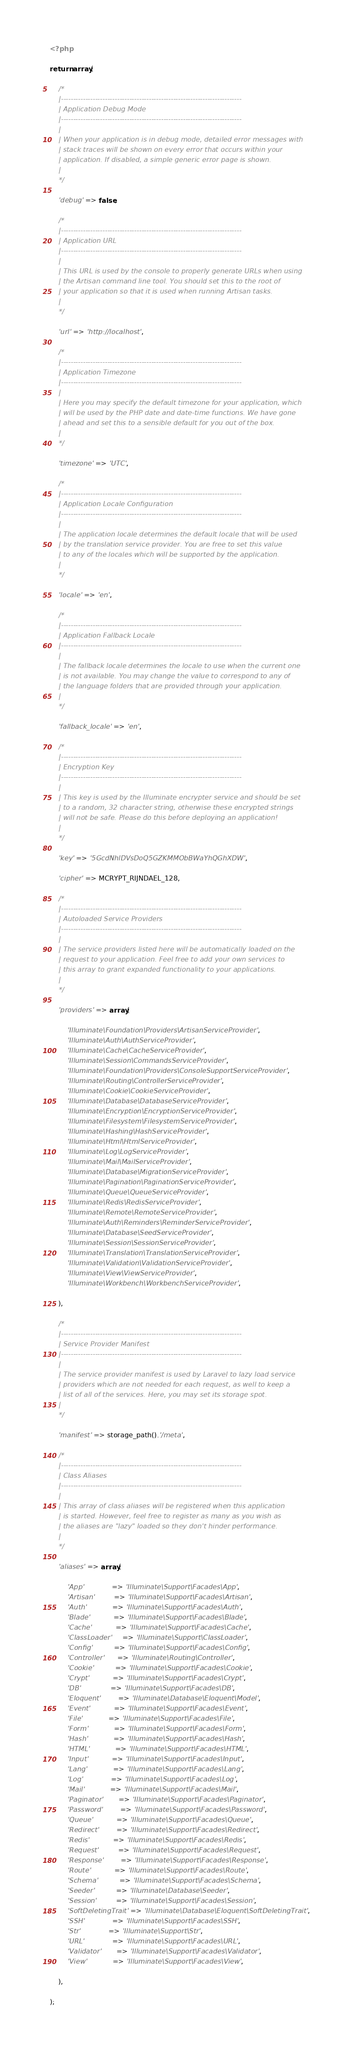Convert code to text. <code><loc_0><loc_0><loc_500><loc_500><_PHP_><?php

return array(

	/*
	|--------------------------------------------------------------------------
	| Application Debug Mode
	|--------------------------------------------------------------------------
	|
	| When your application is in debug mode, detailed error messages with
	| stack traces will be shown on every error that occurs within your
	| application. If disabled, a simple generic error page is shown.
	|
	*/

	'debug' => false,

	/*
	|--------------------------------------------------------------------------
	| Application URL
	|--------------------------------------------------------------------------
	|
	| This URL is used by the console to properly generate URLs when using
	| the Artisan command line tool. You should set this to the root of
	| your application so that it is used when running Artisan tasks.
	|
	*/

	'url' => 'http://localhost',

	/*
	|--------------------------------------------------------------------------
	| Application Timezone
	|--------------------------------------------------------------------------
	|
	| Here you may specify the default timezone for your application, which
	| will be used by the PHP date and date-time functions. We have gone
	| ahead and set this to a sensible default for you out of the box.
	|
	*/

	'timezone' => 'UTC',

	/*
	|--------------------------------------------------------------------------
	| Application Locale Configuration
	|--------------------------------------------------------------------------
	|
	| The application locale determines the default locale that will be used
	| by the translation service provider. You are free to set this value
	| to any of the locales which will be supported by the application.
	|
	*/

	'locale' => 'en',

	/*
	|--------------------------------------------------------------------------
	| Application Fallback Locale
	|--------------------------------------------------------------------------
	|
	| The fallback locale determines the locale to use when the current one
	| is not available. You may change the value to correspond to any of
	| the language folders that are provided through your application.
	|
	*/

	'fallback_locale' => 'en',

	/*
	|--------------------------------------------------------------------------
	| Encryption Key
	|--------------------------------------------------------------------------
	|
	| This key is used by the Illuminate encrypter service and should be set
	| to a random, 32 character string, otherwise these encrypted strings
	| will not be safe. Please do this before deploying an application!
	|
	*/

	'key' => '5GcdNhlDVsDoQ5GZKMMObBWaYhQGhXDW',

	'cipher' => MCRYPT_RIJNDAEL_128,

	/*
	|--------------------------------------------------------------------------
	| Autoloaded Service Providers
	|--------------------------------------------------------------------------
	|
	| The service providers listed here will be automatically loaded on the
	| request to your application. Feel free to add your own services to
	| this array to grant expanded functionality to your applications.
	|
	*/

	'providers' => array(

		'Illuminate\Foundation\Providers\ArtisanServiceProvider',
		'Illuminate\Auth\AuthServiceProvider',
		'Illuminate\Cache\CacheServiceProvider',
		'Illuminate\Session\CommandsServiceProvider',
		'Illuminate\Foundation\Providers\ConsoleSupportServiceProvider',
		'Illuminate\Routing\ControllerServiceProvider',
		'Illuminate\Cookie\CookieServiceProvider',
		'Illuminate\Database\DatabaseServiceProvider',
		'Illuminate\Encryption\EncryptionServiceProvider',
		'Illuminate\Filesystem\FilesystemServiceProvider',
		'Illuminate\Hashing\HashServiceProvider',
		'Illuminate\Html\HtmlServiceProvider',
		'Illuminate\Log\LogServiceProvider',
		'Illuminate\Mail\MailServiceProvider',
		'Illuminate\Database\MigrationServiceProvider',
		'Illuminate\Pagination\PaginationServiceProvider',
		'Illuminate\Queue\QueueServiceProvider',
		'Illuminate\Redis\RedisServiceProvider',
		'Illuminate\Remote\RemoteServiceProvider',
		'Illuminate\Auth\Reminders\ReminderServiceProvider',
		'Illuminate\Database\SeedServiceProvider',
		'Illuminate\Session\SessionServiceProvider',
		'Illuminate\Translation\TranslationServiceProvider',
		'Illuminate\Validation\ValidationServiceProvider',
		'Illuminate\View\ViewServiceProvider',
		'Illuminate\Workbench\WorkbenchServiceProvider',

	),

	/*
	|--------------------------------------------------------------------------
	| Service Provider Manifest
	|--------------------------------------------------------------------------
	|
	| The service provider manifest is used by Laravel to lazy load service
	| providers which are not needed for each request, as well to keep a
	| list of all of the services. Here, you may set its storage spot.
	|
	*/

	'manifest' => storage_path().'/meta',

	/*
	|--------------------------------------------------------------------------
	| Class Aliases
	|--------------------------------------------------------------------------
	|
	| This array of class aliases will be registered when this application
	| is started. However, feel free to register as many as you wish as
	| the aliases are "lazy" loaded so they don't hinder performance.
	|
	*/

	'aliases' => array(

		'App'             => 'Illuminate\Support\Facades\App',
		'Artisan'         => 'Illuminate\Support\Facades\Artisan',
		'Auth'            => 'Illuminate\Support\Facades\Auth',
		'Blade'           => 'Illuminate\Support\Facades\Blade',
		'Cache'           => 'Illuminate\Support\Facades\Cache',
		'ClassLoader'     => 'Illuminate\Support\ClassLoader',
		'Config'          => 'Illuminate\Support\Facades\Config',
		'Controller'      => 'Illuminate\Routing\Controller',
		'Cookie'          => 'Illuminate\Support\Facades\Cookie',
		'Crypt'           => 'Illuminate\Support\Facades\Crypt',
		'DB'              => 'Illuminate\Support\Facades\DB',
		'Eloquent'        => 'Illuminate\Database\Eloquent\Model',
		'Event'           => 'Illuminate\Support\Facades\Event',
		'File'            => 'Illuminate\Support\Facades\File',
		'Form'            => 'Illuminate\Support\Facades\Form',
		'Hash'            => 'Illuminate\Support\Facades\Hash',
		'HTML'            => 'Illuminate\Support\Facades\HTML',
		'Input'           => 'Illuminate\Support\Facades\Input',
		'Lang'            => 'Illuminate\Support\Facades\Lang',
		'Log'             => 'Illuminate\Support\Facades\Log',
		'Mail'            => 'Illuminate\Support\Facades\Mail',
		'Paginator'       => 'Illuminate\Support\Facades\Paginator',
		'Password'        => 'Illuminate\Support\Facades\Password',
		'Queue'           => 'Illuminate\Support\Facades\Queue',
		'Redirect'        => 'Illuminate\Support\Facades\Redirect',
		'Redis'           => 'Illuminate\Support\Facades\Redis',
		'Request'         => 'Illuminate\Support\Facades\Request',
		'Response'        => 'Illuminate\Support\Facades\Response',
		'Route'           => 'Illuminate\Support\Facades\Route',
		'Schema'          => 'Illuminate\Support\Facades\Schema',
		'Seeder'          => 'Illuminate\Database\Seeder',
		'Session'         => 'Illuminate\Support\Facades\Session',
		'SoftDeletingTrait' => 'Illuminate\Database\Eloquent\SoftDeletingTrait',
		'SSH'             => 'Illuminate\Support\Facades\SSH',
		'Str'             => 'Illuminate\Support\Str',
		'URL'             => 'Illuminate\Support\Facades\URL',
		'Validator'       => 'Illuminate\Support\Facades\Validator',
		'View'            => 'Illuminate\Support\Facades\View',

	),

);
</code> 